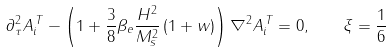Convert formula to latex. <formula><loc_0><loc_0><loc_500><loc_500>\partial _ { \tau } ^ { 2 } A _ { i } ^ { \, T } - \left ( 1 + \frac { 3 } { 8 } \beta _ { e } \frac { H ^ { 2 } } { M _ { s } ^ { 2 } } \left ( 1 + w \right ) \right ) \nabla ^ { 2 } A _ { i } ^ { \, T } = 0 , \quad \xi = \frac { 1 } { 6 }</formula> 